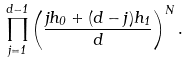Convert formula to latex. <formula><loc_0><loc_0><loc_500><loc_500>\prod _ { j = 1 } ^ { d - 1 } \left ( \frac { j h _ { 0 } + ( d - j ) h _ { 1 } } { d } \right ) ^ { N } .</formula> 